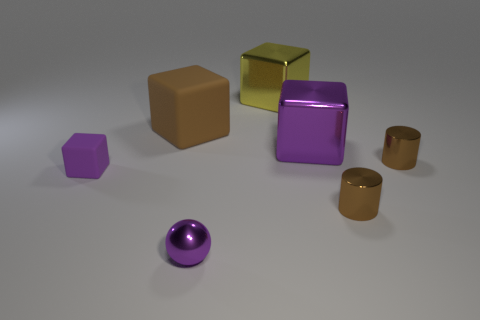Subtract all green cubes. Subtract all blue cylinders. How many cubes are left? 4 Subtract all cylinders. How many objects are left? 5 Add 2 large purple metal blocks. How many objects exist? 9 Subtract 0 blue cubes. How many objects are left? 7 Subtract all large brown matte cubes. Subtract all purple rubber cylinders. How many objects are left? 6 Add 4 brown shiny cylinders. How many brown shiny cylinders are left? 6 Add 4 purple matte objects. How many purple matte objects exist? 5 